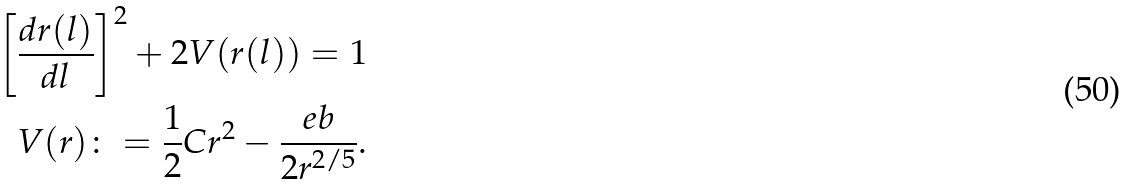<formula> <loc_0><loc_0><loc_500><loc_500>\left [ \frac { d r ( l ) } { d l } \right ] ^ { 2 } + 2 V ( r ( l ) ) = 1 \\ V ( r ) \colon = \frac { 1 } { 2 } C r ^ { 2 } - \frac { e b } { 2 r ^ { 2 / 5 } } .</formula> 